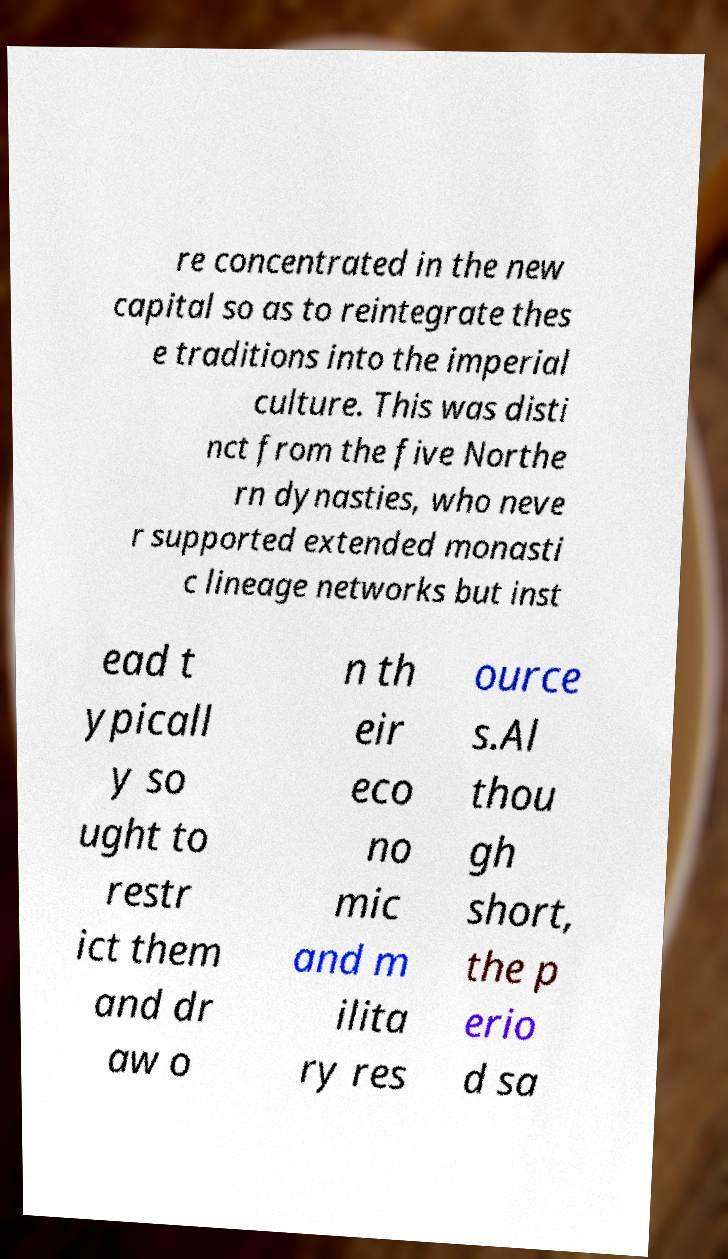I need the written content from this picture converted into text. Can you do that? re concentrated in the new capital so as to reintegrate thes e traditions into the imperial culture. This was disti nct from the five Northe rn dynasties, who neve r supported extended monasti c lineage networks but inst ead t ypicall y so ught to restr ict them and dr aw o n th eir eco no mic and m ilita ry res ource s.Al thou gh short, the p erio d sa 